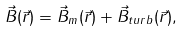<formula> <loc_0><loc_0><loc_500><loc_500>\vec { B } ( \vec { r } ) = \vec { B } _ { m } ( \vec { r } ) + \vec { B } _ { t u r b } ( \vec { r } ) ,</formula> 